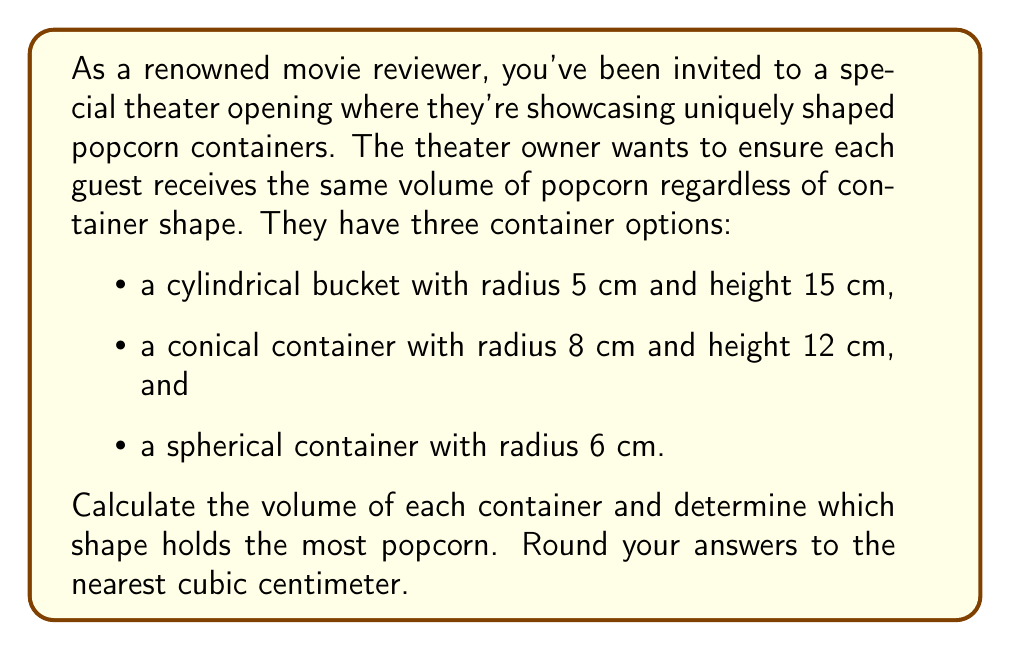What is the answer to this math problem? Let's calculate the volume of each container:

1. Cylindrical bucket:
   The volume of a cylinder is given by $V = \pi r^2 h$
   $$V_{cylinder} = \pi (5\text{ cm})^2 (15\text{ cm}) = 1178.10\text{ cm}^3$$

2. Conical container:
   The volume of a cone is given by $V = \frac{1}{3}\pi r^2 h$
   $$V_{cone} = \frac{1}{3}\pi (8\text{ cm})^2 (12\text{ cm}) = 804.25\text{ cm}^3$$

3. Spherical container:
   The volume of a sphere is given by $V = \frac{4}{3}\pi r^3$
   $$V_{sphere} = \frac{4}{3}\pi (6\text{ cm})^3 = 904.78\text{ cm}^3$$

Rounding to the nearest cubic centimeter:
- Cylinder: 1178 cm³
- Cone: 804 cm³
- Sphere: 905 cm³

Comparing these volumes, we can see that the cylindrical bucket holds the most popcorn.
Answer: The cylindrical bucket holds the most popcorn with a volume of 1178 cm³, followed by the spherical container with 905 cm³, and finally the conical container with 804 cm³. 